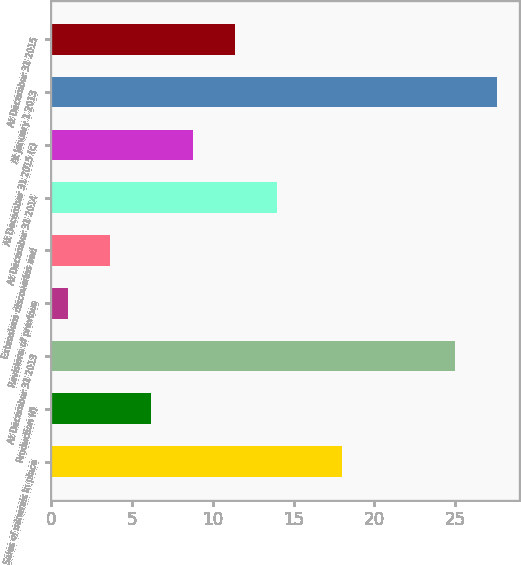<chart> <loc_0><loc_0><loc_500><loc_500><bar_chart><fcel>Sales of minerals in place<fcel>Production (f)<fcel>At December 31 2013<fcel>Revisions of previous<fcel>Extensions discoveries and<fcel>At December 31 2014<fcel>At December 31 2015 (c)<fcel>At January 1 2013<fcel>At December 31 2015<nl><fcel>18<fcel>6.2<fcel>25<fcel>1<fcel>3.6<fcel>14<fcel>8.8<fcel>27.6<fcel>11.4<nl></chart> 